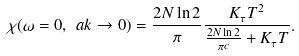<formula> <loc_0><loc_0><loc_500><loc_500>\chi ( \omega = 0 , \ a k \rightarrow 0 ) = \frac { 2 N \ln 2 } { \pi } \frac { K _ { \tau } T ^ { 2 } } { \frac { 2 N \ln 2 } { \pi c } + K _ { \tau } T } .</formula> 